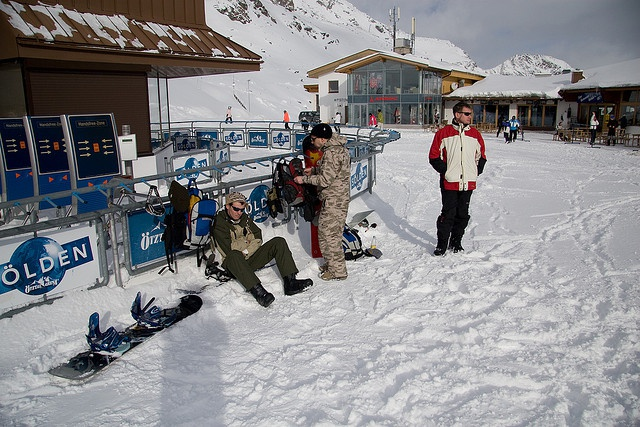Describe the objects in this image and their specific colors. I can see people in gray, black, and darkgray tones, people in gray, black, lightgray, and brown tones, people in gray, darkgray, and black tones, snowboard in gray, black, darkgray, and navy tones, and backpack in gray, black, navy, and darkgray tones in this image. 